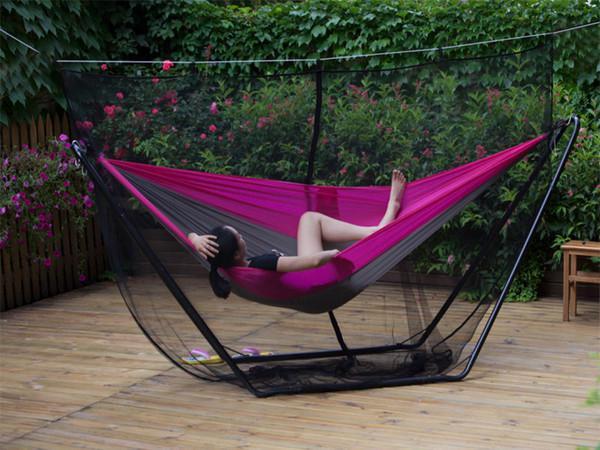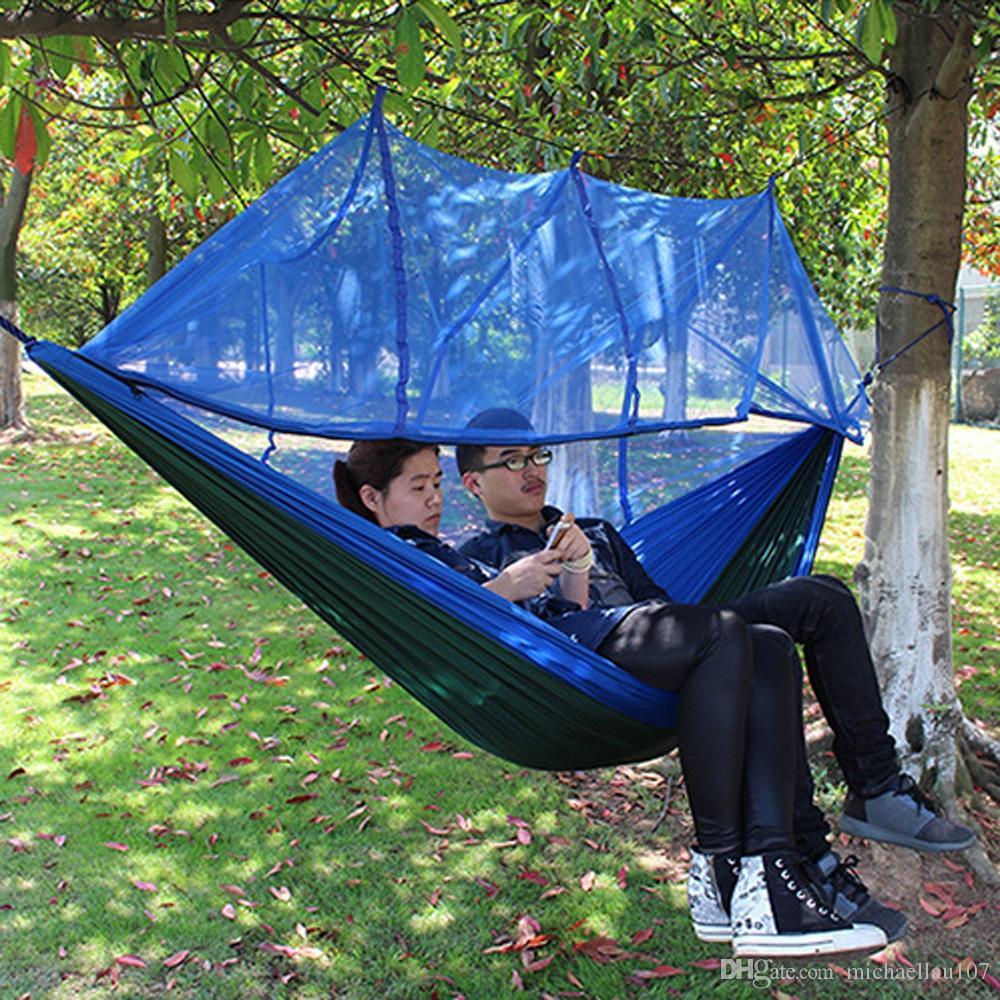The first image is the image on the left, the second image is the image on the right. Analyze the images presented: Is the assertion "A blue hammock hangs from a tree in one of the images." valid? Answer yes or no. Yes. The first image is the image on the left, the second image is the image on the right. For the images displayed, is the sentence "An image shows a hanging hammock that does not contain a person." factually correct? Answer yes or no. No. 